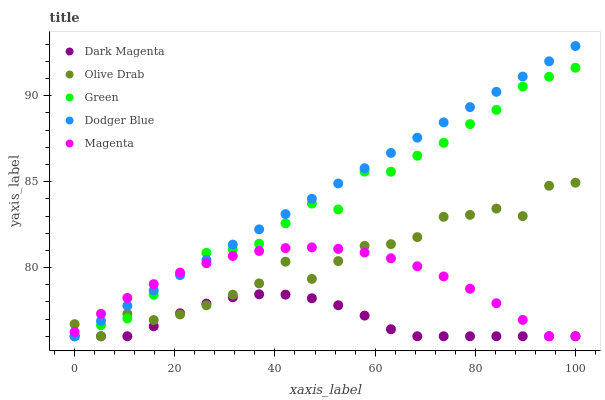Does Dark Magenta have the minimum area under the curve?
Answer yes or no. Yes. Does Dodger Blue have the maximum area under the curve?
Answer yes or no. Yes. Does Magenta have the minimum area under the curve?
Answer yes or no. No. Does Magenta have the maximum area under the curve?
Answer yes or no. No. Is Dodger Blue the smoothest?
Answer yes or no. Yes. Is Olive Drab the roughest?
Answer yes or no. Yes. Is Magenta the smoothest?
Answer yes or no. No. Is Magenta the roughest?
Answer yes or no. No. Does Dodger Blue have the lowest value?
Answer yes or no. Yes. Does Dodger Blue have the highest value?
Answer yes or no. Yes. Does Magenta have the highest value?
Answer yes or no. No. Does Olive Drab intersect Dark Magenta?
Answer yes or no. Yes. Is Olive Drab less than Dark Magenta?
Answer yes or no. No. Is Olive Drab greater than Dark Magenta?
Answer yes or no. No. 